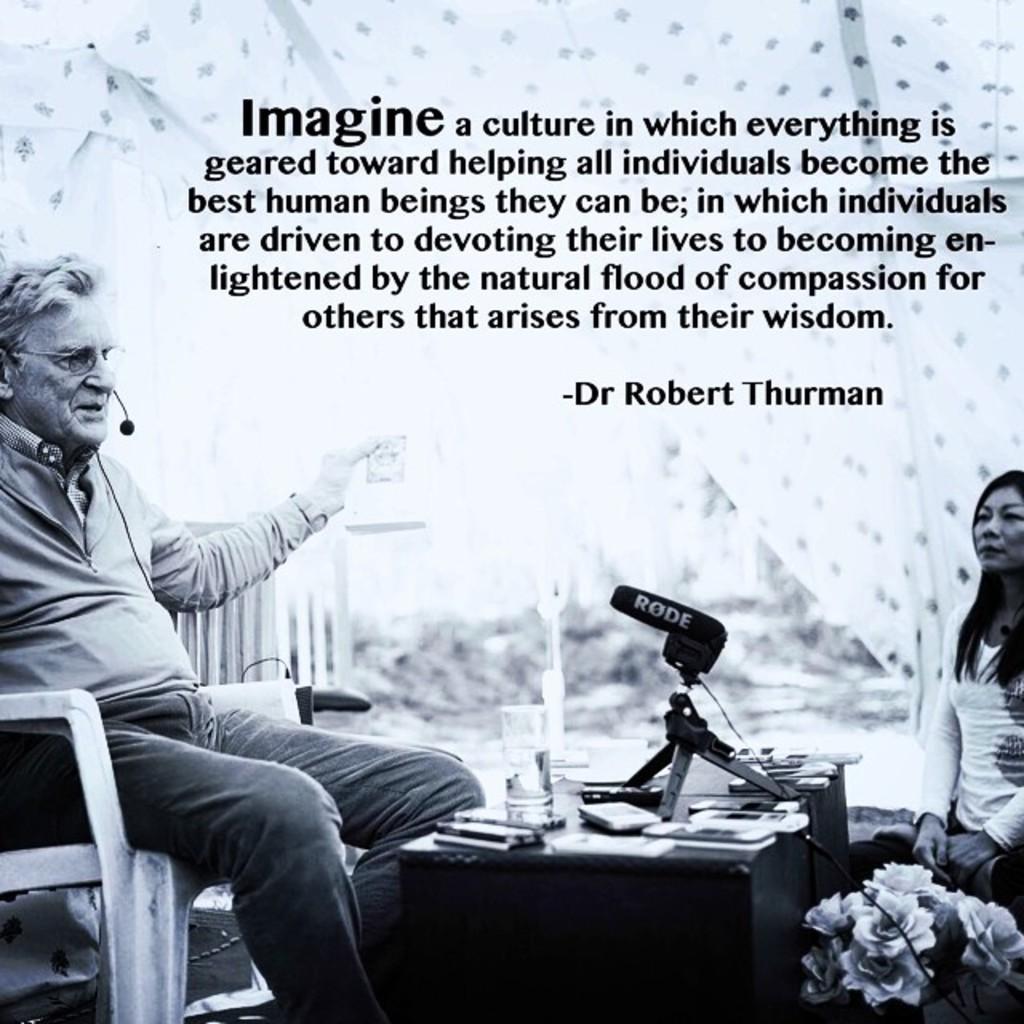Could you give a brief overview of what you see in this image? This looks like a black and white poster. These are the letters on the poster. I can see a man sitting on the chair. He is holding an object. This is the table with a glass of water, mobile phones and a mike with the stand. These are the bunch of flowers. Here is the woman sitting. 